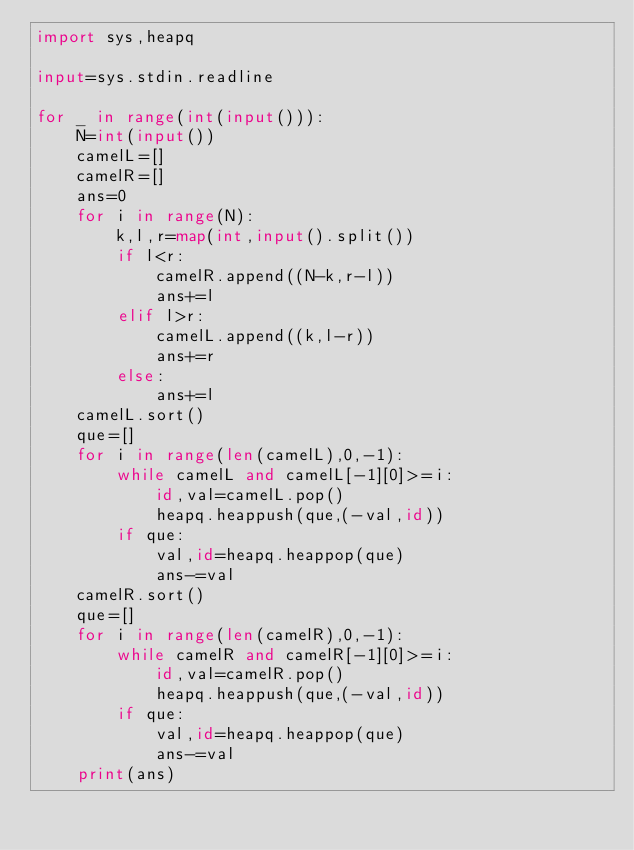<code> <loc_0><loc_0><loc_500><loc_500><_Python_>import sys,heapq

input=sys.stdin.readline

for _ in range(int(input())):
    N=int(input())
    camelL=[]
    camelR=[]
    ans=0
    for i in range(N):
        k,l,r=map(int,input().split())
        if l<r:
            camelR.append((N-k,r-l))
            ans+=l
        elif l>r:
            camelL.append((k,l-r))
            ans+=r
        else:
            ans+=l
    camelL.sort()
    que=[]
    for i in range(len(camelL),0,-1):
        while camelL and camelL[-1][0]>=i:
            id,val=camelL.pop()
            heapq.heappush(que,(-val,id))
        if que:
            val,id=heapq.heappop(que)
            ans-=val
    camelR.sort()
    que=[]
    for i in range(len(camelR),0,-1):
        while camelR and camelR[-1][0]>=i:
            id,val=camelR.pop()
            heapq.heappush(que,(-val,id))
        if que:
            val,id=heapq.heappop(que)
            ans-=val
    print(ans)</code> 